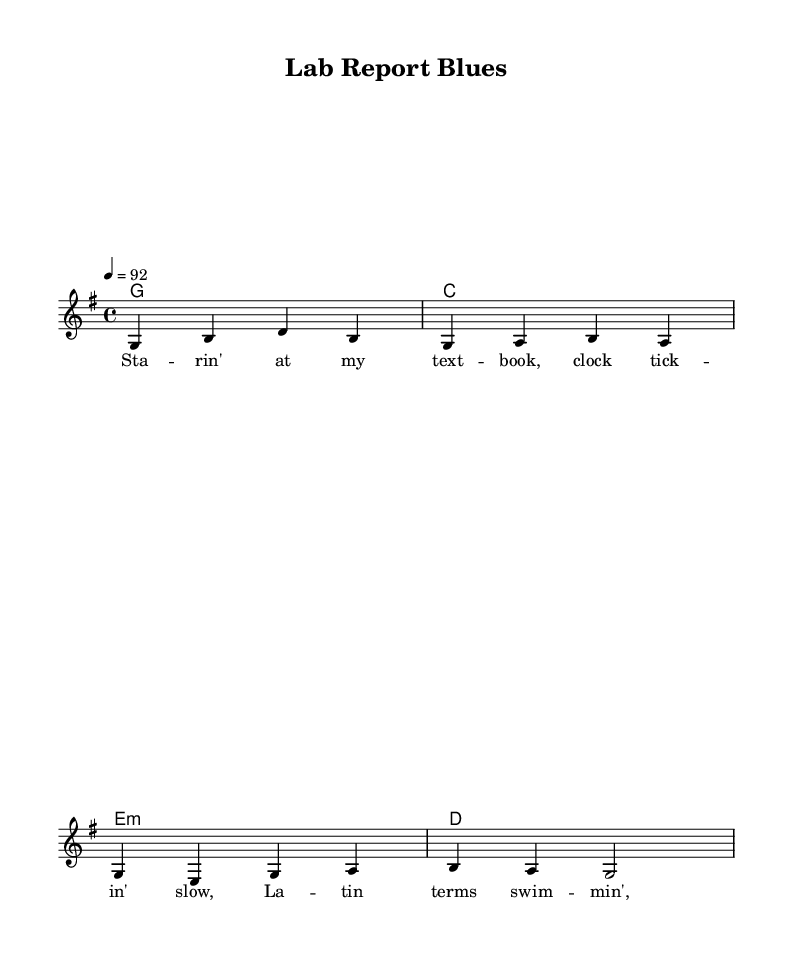What is the key signature of this music? The key signature is G major, which has one sharp (F#). It is identifiable by looking at the sheet music where the sharps are indicated.
Answer: G major What is the time signature of this piece? The time signature is 4/4, which means there are four beats in a measure and the quarter note gets one beat. This can be found at the beginning of the staff notation.
Answer: 4/4 What is the tempo marking of the piece? The tempo marking is 92 beats per minute (bpm) and is indicated at the beginning of the score, showing how fast the music should be played.
Answer: 92 What is the first note of the melody? The first note of the melody is G, which can be located as the first note on the staff after the key and time signatures.
Answer: G How many measures are in the piece? There are four measures in the piece, which can be counted by looking at the separation between the vertical lines on the staff indicating the end of each measure.
Answer: 4 What type of lyrics are provided in this piece? The lyrics reflect struggles and situations common to college students, specifically referring to studying and the challenges of Latin terms. This is derived from the content of the lyrics provided in the score.
Answer: College struggles What chord is played with the first measure? The chord played in the first measure is G major, and this is deduced from the chord symbols written above the melody in the score.
Answer: G 